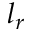Convert formula to latex. <formula><loc_0><loc_0><loc_500><loc_500>l _ { r }</formula> 